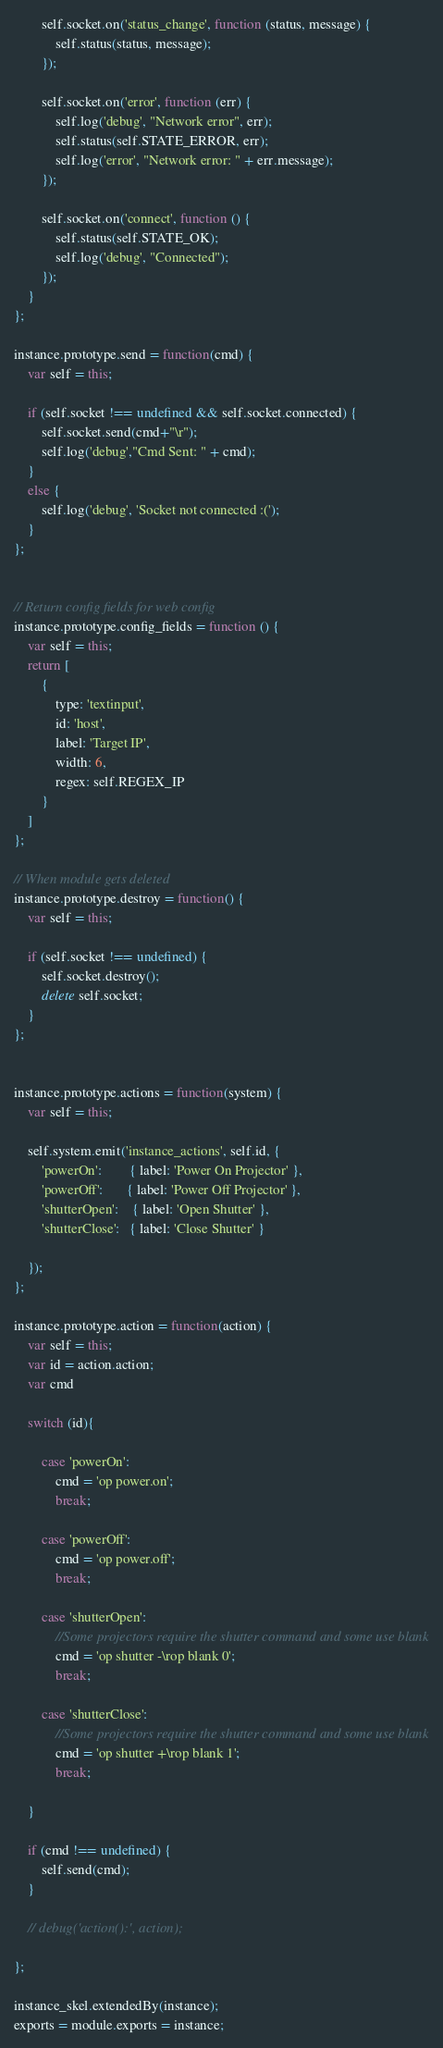<code> <loc_0><loc_0><loc_500><loc_500><_JavaScript_>		self.socket.on('status_change', function (status, message) {
			self.status(status, message);
		});

		self.socket.on('error', function (err) {
			self.log('debug', "Network error", err);
			self.status(self.STATE_ERROR, err);
			self.log('error', "Network error: " + err.message);
		});

		self.socket.on('connect', function () {
			self.status(self.STATE_OK);
			self.log('debug', "Connected");
		});
	}
};

instance.prototype.send = function(cmd) {
	var self = this;

	if (self.socket !== undefined && self.socket.connected) {
		self.socket.send(cmd+"\r");
		self.log('debug',"Cmd Sent: " + cmd);
	}
	else {
		self.log('debug', 'Socket not connected :(');
	}
};


// Return config fields for web config
instance.prototype.config_fields = function () {
	var self = this;
	return [
		{
			type: 'textinput',
			id: 'host',
			label: 'Target IP',
			width: 6,
			regex: self.REGEX_IP
		}
	]
};

// When module gets deleted
instance.prototype.destroy = function() {
	var self = this;

	if (self.socket !== undefined) {
		self.socket.destroy();
		delete self.socket;
	}
};


instance.prototype.actions = function(system) {
	var self = this;

	self.system.emit('instance_actions', self.id, {
		'powerOn':        { label: 'Power On Projector' },
		'powerOff':       { label: 'Power Off Projector' },
		'shutterOpen':    { label: 'Open Shutter' },
		'shutterClose':   { label: 'Close Shutter' }

	});
};

instance.prototype.action = function(action) {
	var self = this;
	var id = action.action;
	var cmd

	switch (id){

		case 'powerOn':
			cmd = 'op power.on';
			break;

		case 'powerOff':
			cmd = 'op power.off';
			break;

		case 'shutterOpen':
			//Some projectors require the shutter command and some use blank
			cmd = 'op shutter -\rop blank 0';
			break;

		case 'shutterClose':
			//Some projectors require the shutter command and some use blank
			cmd = 'op shutter +\rop blank 1';
			break;

	}

	if (cmd !== undefined) {
		self.send(cmd);
	}

	// debug('action():', action);

};

instance_skel.extendedBy(instance);
exports = module.exports = instance;
</code> 